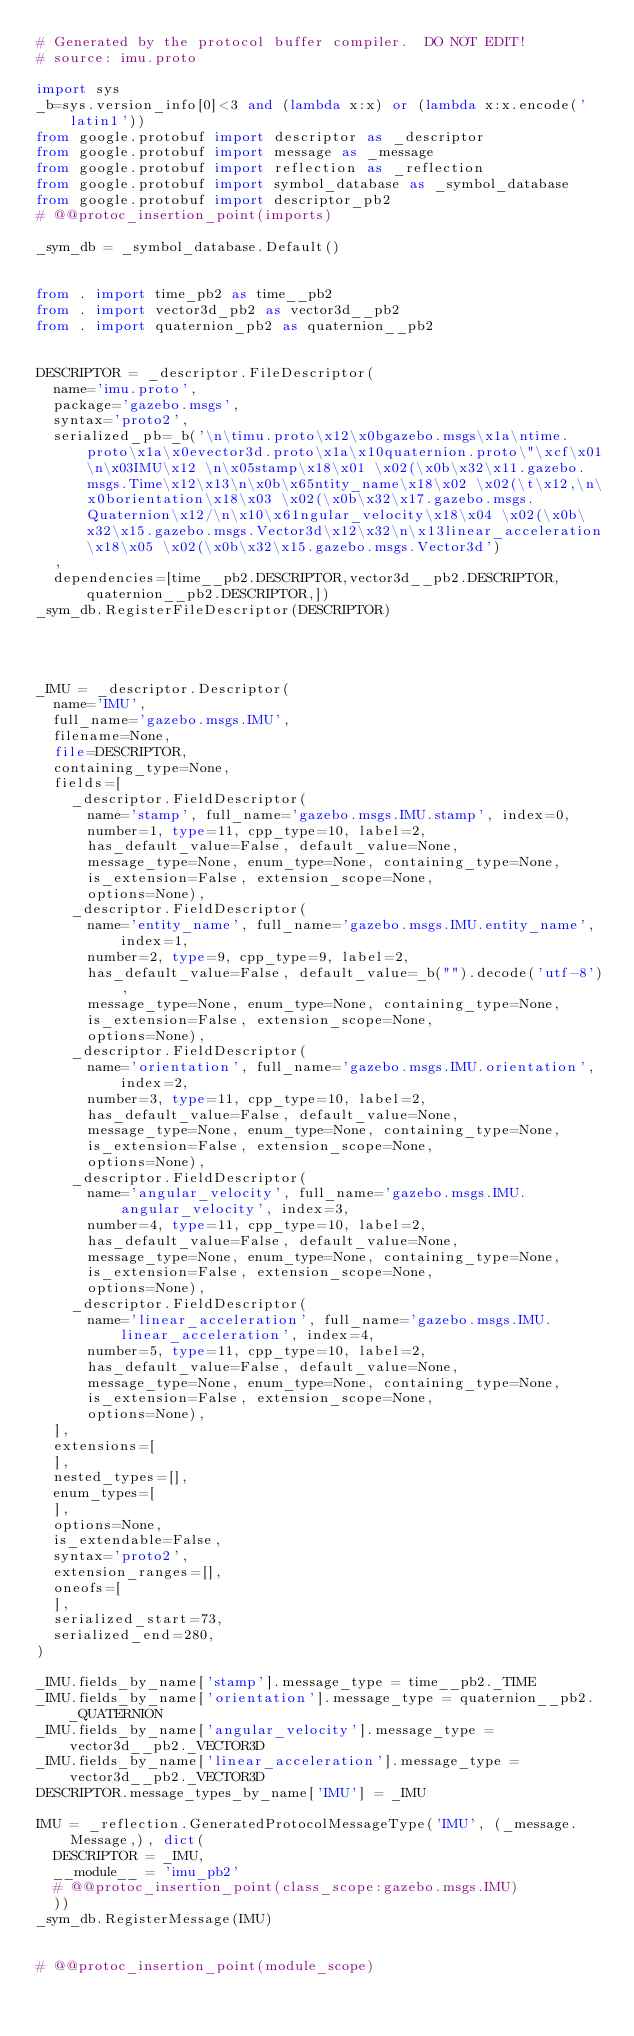<code> <loc_0><loc_0><loc_500><loc_500><_Python_># Generated by the protocol buffer compiler.  DO NOT EDIT!
# source: imu.proto

import sys
_b=sys.version_info[0]<3 and (lambda x:x) or (lambda x:x.encode('latin1'))
from google.protobuf import descriptor as _descriptor
from google.protobuf import message as _message
from google.protobuf import reflection as _reflection
from google.protobuf import symbol_database as _symbol_database
from google.protobuf import descriptor_pb2
# @@protoc_insertion_point(imports)

_sym_db = _symbol_database.Default()


from . import time_pb2 as time__pb2
from . import vector3d_pb2 as vector3d__pb2
from . import quaternion_pb2 as quaternion__pb2


DESCRIPTOR = _descriptor.FileDescriptor(
  name='imu.proto',
  package='gazebo.msgs',
  syntax='proto2',
  serialized_pb=_b('\n\timu.proto\x12\x0bgazebo.msgs\x1a\ntime.proto\x1a\x0evector3d.proto\x1a\x10quaternion.proto\"\xcf\x01\n\x03IMU\x12 \n\x05stamp\x18\x01 \x02(\x0b\x32\x11.gazebo.msgs.Time\x12\x13\n\x0b\x65ntity_name\x18\x02 \x02(\t\x12,\n\x0borientation\x18\x03 \x02(\x0b\x32\x17.gazebo.msgs.Quaternion\x12/\n\x10\x61ngular_velocity\x18\x04 \x02(\x0b\x32\x15.gazebo.msgs.Vector3d\x12\x32\n\x13linear_acceleration\x18\x05 \x02(\x0b\x32\x15.gazebo.msgs.Vector3d')
  ,
  dependencies=[time__pb2.DESCRIPTOR,vector3d__pb2.DESCRIPTOR,quaternion__pb2.DESCRIPTOR,])
_sym_db.RegisterFileDescriptor(DESCRIPTOR)




_IMU = _descriptor.Descriptor(
  name='IMU',
  full_name='gazebo.msgs.IMU',
  filename=None,
  file=DESCRIPTOR,
  containing_type=None,
  fields=[
    _descriptor.FieldDescriptor(
      name='stamp', full_name='gazebo.msgs.IMU.stamp', index=0,
      number=1, type=11, cpp_type=10, label=2,
      has_default_value=False, default_value=None,
      message_type=None, enum_type=None, containing_type=None,
      is_extension=False, extension_scope=None,
      options=None),
    _descriptor.FieldDescriptor(
      name='entity_name', full_name='gazebo.msgs.IMU.entity_name', index=1,
      number=2, type=9, cpp_type=9, label=2,
      has_default_value=False, default_value=_b("").decode('utf-8'),
      message_type=None, enum_type=None, containing_type=None,
      is_extension=False, extension_scope=None,
      options=None),
    _descriptor.FieldDescriptor(
      name='orientation', full_name='gazebo.msgs.IMU.orientation', index=2,
      number=3, type=11, cpp_type=10, label=2,
      has_default_value=False, default_value=None,
      message_type=None, enum_type=None, containing_type=None,
      is_extension=False, extension_scope=None,
      options=None),
    _descriptor.FieldDescriptor(
      name='angular_velocity', full_name='gazebo.msgs.IMU.angular_velocity', index=3,
      number=4, type=11, cpp_type=10, label=2,
      has_default_value=False, default_value=None,
      message_type=None, enum_type=None, containing_type=None,
      is_extension=False, extension_scope=None,
      options=None),
    _descriptor.FieldDescriptor(
      name='linear_acceleration', full_name='gazebo.msgs.IMU.linear_acceleration', index=4,
      number=5, type=11, cpp_type=10, label=2,
      has_default_value=False, default_value=None,
      message_type=None, enum_type=None, containing_type=None,
      is_extension=False, extension_scope=None,
      options=None),
  ],
  extensions=[
  ],
  nested_types=[],
  enum_types=[
  ],
  options=None,
  is_extendable=False,
  syntax='proto2',
  extension_ranges=[],
  oneofs=[
  ],
  serialized_start=73,
  serialized_end=280,
)

_IMU.fields_by_name['stamp'].message_type = time__pb2._TIME
_IMU.fields_by_name['orientation'].message_type = quaternion__pb2._QUATERNION
_IMU.fields_by_name['angular_velocity'].message_type = vector3d__pb2._VECTOR3D
_IMU.fields_by_name['linear_acceleration'].message_type = vector3d__pb2._VECTOR3D
DESCRIPTOR.message_types_by_name['IMU'] = _IMU

IMU = _reflection.GeneratedProtocolMessageType('IMU', (_message.Message,), dict(
  DESCRIPTOR = _IMU,
  __module__ = 'imu_pb2'
  # @@protoc_insertion_point(class_scope:gazebo.msgs.IMU)
  ))
_sym_db.RegisterMessage(IMU)


# @@protoc_insertion_point(module_scope)
</code> 